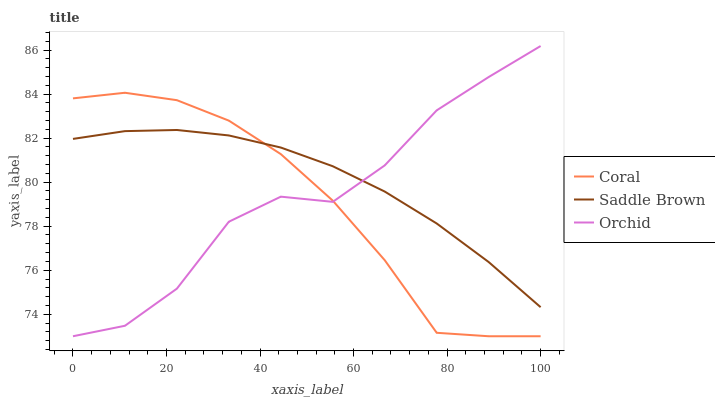Does Orchid have the minimum area under the curve?
Answer yes or no. No. Does Orchid have the maximum area under the curve?
Answer yes or no. No. Is Orchid the smoothest?
Answer yes or no. No. Is Saddle Brown the roughest?
Answer yes or no. No. Does Saddle Brown have the lowest value?
Answer yes or no. No. Does Saddle Brown have the highest value?
Answer yes or no. No. 